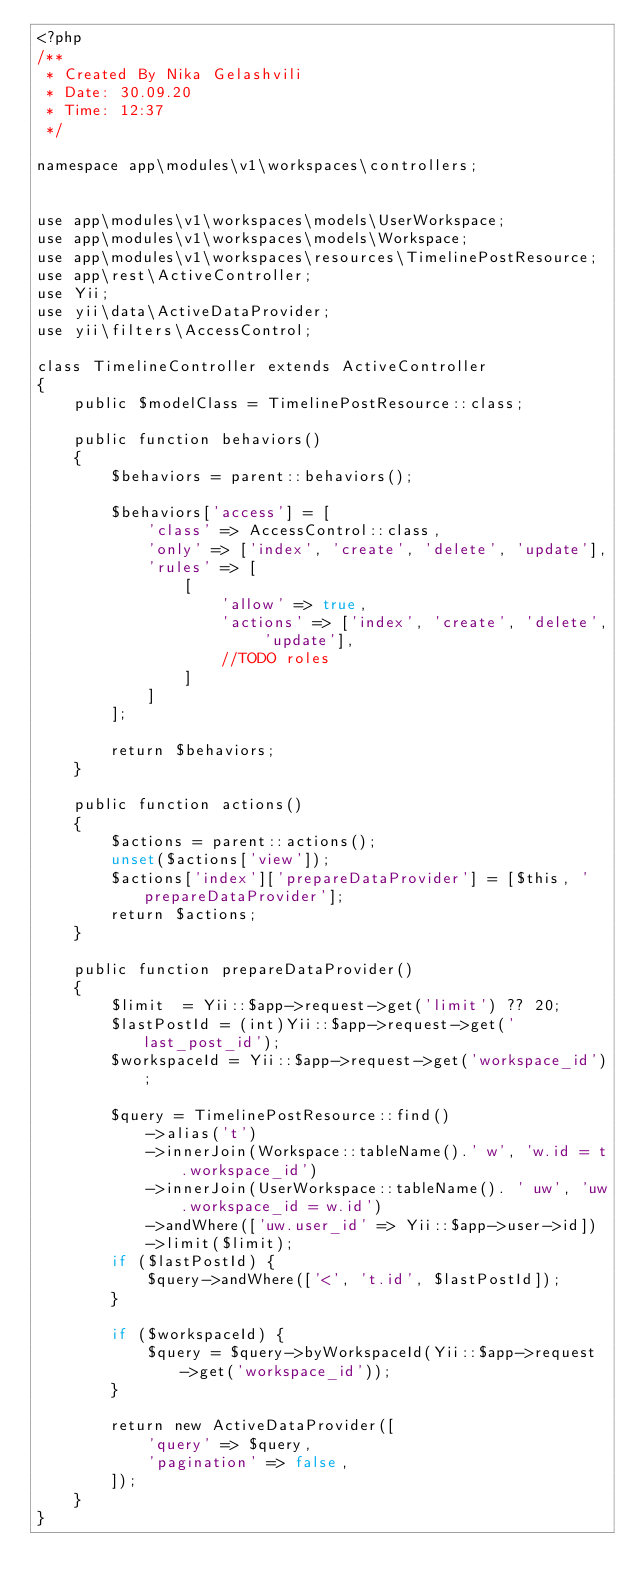<code> <loc_0><loc_0><loc_500><loc_500><_PHP_><?php
/**
 * Created By Nika Gelashvili
 * Date: 30.09.20
 * Time: 12:37
 */

namespace app\modules\v1\workspaces\controllers;


use app\modules\v1\workspaces\models\UserWorkspace;
use app\modules\v1\workspaces\models\Workspace;
use app\modules\v1\workspaces\resources\TimelinePostResource;
use app\rest\ActiveController;
use Yii;
use yii\data\ActiveDataProvider;
use yii\filters\AccessControl;

class TimelineController extends ActiveController
{
    public $modelClass = TimelinePostResource::class;

    public function behaviors()
    {
        $behaviors = parent::behaviors();

        $behaviors['access'] = [
            'class' => AccessControl::class,
            'only' => ['index', 'create', 'delete', 'update'],
            'rules' => [
                [
                    'allow' => true,
                    'actions' => ['index', 'create', 'delete', 'update'],
                    //TODO roles
                ]
            ]
        ];

        return $behaviors;
    }

    public function actions()
    {
        $actions = parent::actions();
        unset($actions['view']);
        $actions['index']['prepareDataProvider'] = [$this, 'prepareDataProvider'];
        return $actions;
    }

    public function prepareDataProvider()
    {
        $limit  = Yii::$app->request->get('limit') ?? 20;
        $lastPostId = (int)Yii::$app->request->get('last_post_id');
        $workspaceId = Yii::$app->request->get('workspace_id');

        $query = TimelinePostResource::find()
            ->alias('t')
            ->innerJoin(Workspace::tableName().' w', 'w.id = t.workspace_id')
            ->innerJoin(UserWorkspace::tableName(). ' uw', 'uw.workspace_id = w.id')
            ->andWhere(['uw.user_id' => Yii::$app->user->id])
            ->limit($limit);
        if ($lastPostId) {
            $query->andWhere(['<', 't.id', $lastPostId]);
        }

        if ($workspaceId) {
            $query = $query->byWorkspaceId(Yii::$app->request->get('workspace_id'));
        }

        return new ActiveDataProvider([
            'query' => $query,
            'pagination' => false,
        ]);
    }
}</code> 